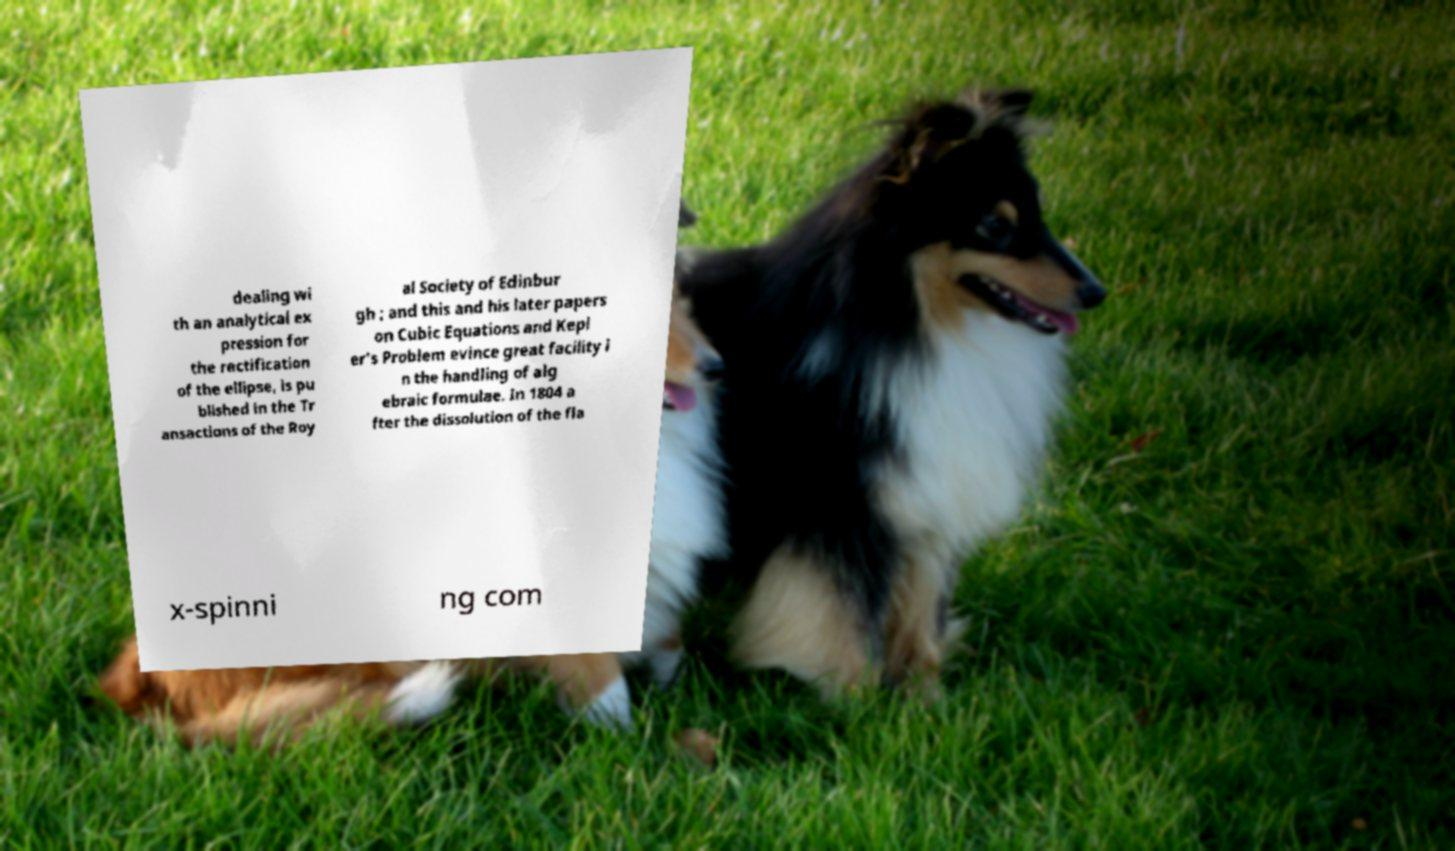Please read and relay the text visible in this image. What does it say? dealing wi th an analytical ex pression for the rectification of the ellipse, is pu blished in the Tr ansactions of the Roy al Society of Edinbur gh ; and this and his later papers on Cubic Equations and Kepl er's Problem evince great facility i n the handling of alg ebraic formulae. In 1804 a fter the dissolution of the fla x-spinni ng com 